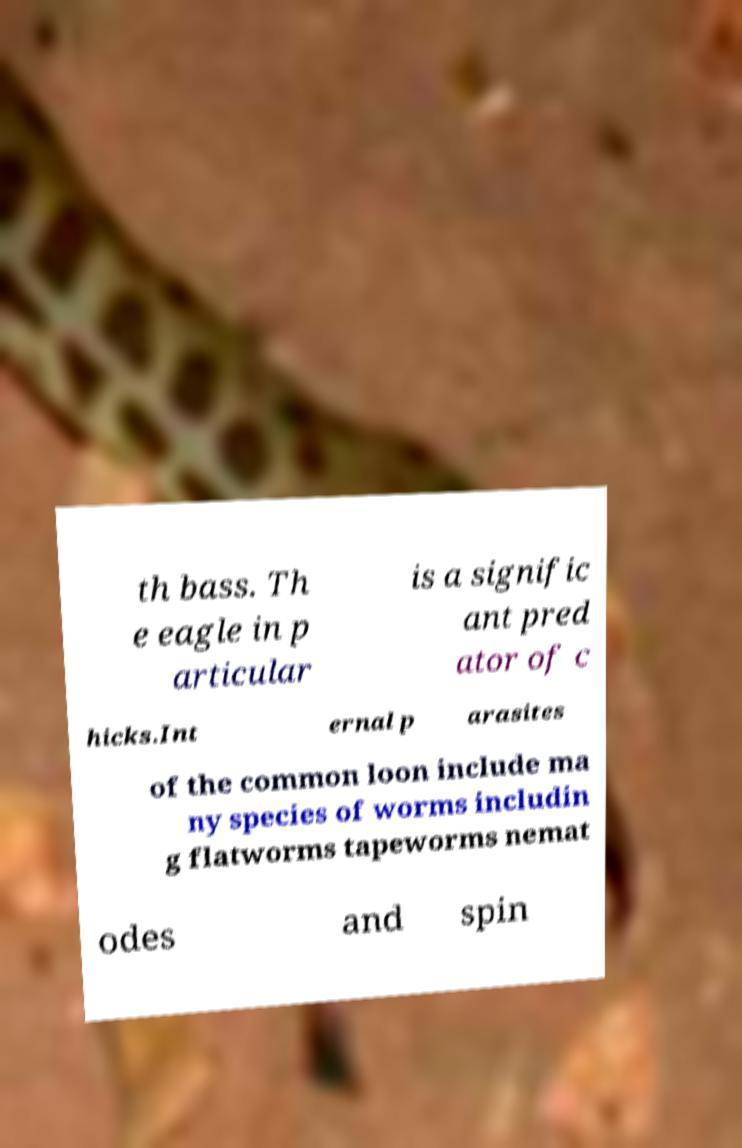Can you accurately transcribe the text from the provided image for me? th bass. Th e eagle in p articular is a signific ant pred ator of c hicks.Int ernal p arasites of the common loon include ma ny species of worms includin g flatworms tapeworms nemat odes and spin 